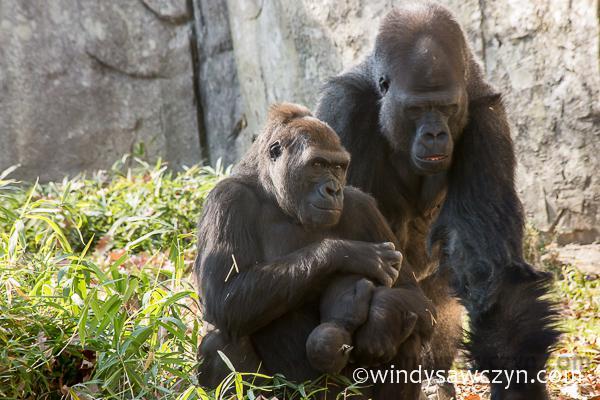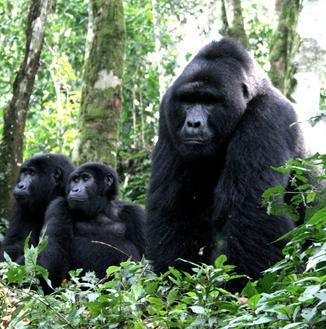The first image is the image on the left, the second image is the image on the right. Evaluate the accuracy of this statement regarding the images: "An image shows exactly one ape, sitting and holding something in its hand.". Is it true? Answer yes or no. No. The first image is the image on the left, the second image is the image on the right. Considering the images on both sides, is "There is a single ape holding something in the left image" valid? Answer yes or no. No. 